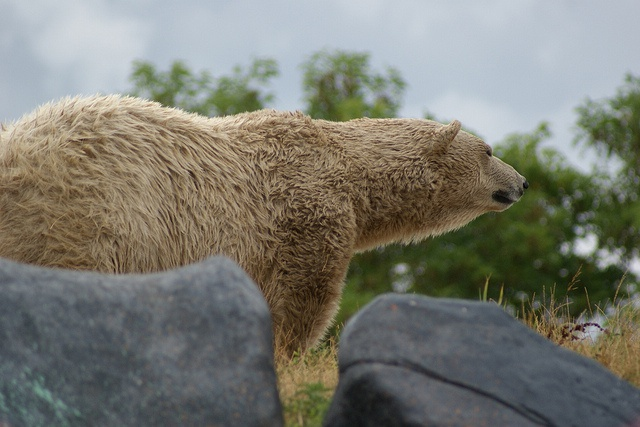Describe the objects in this image and their specific colors. I can see a bear in lightgray, gray, and tan tones in this image. 